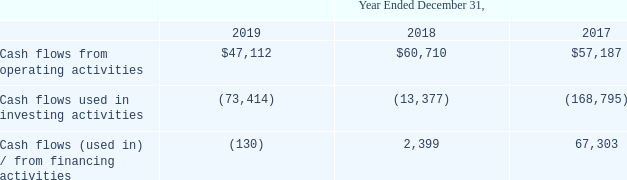Historical Cash Flows
The following table sets forth our cash flows for the periods indicated (in thousands):
Which years does the table provide information for the company's cash flows for? 2019, 2018, 2017. What was the Cash flows (used in) / from financing activities in 2019?
Answer scale should be: thousand. (130). What was the Cash flows used in investing activities in 2017
Answer scale should be: thousand. (168,795). What was the change in Cash flows from operating activities between 2017 and 2018?
Answer scale should be: thousand. 60,710-57,187
Answer: 3523. What was the sum of cash flows in 2019?
Answer scale should be: thousand. 47,112-73,414-130
Answer: -26432. What was the percentage change in the Cash flows (used in) / from financing activities between 2017 and 2018?
Answer scale should be: percent. (2,399-67,303)/67,303
Answer: -96.44. 